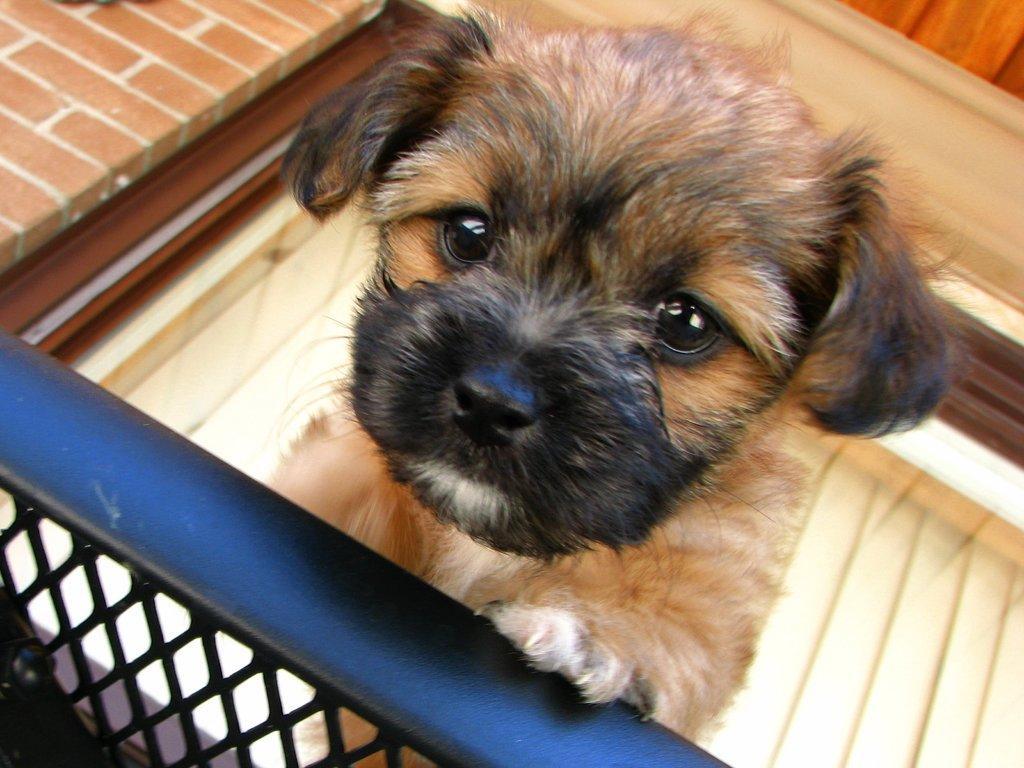Could you give a brief overview of what you see in this image? In this image I can see a puppy is looking at the picture. At the bottom there is a railing. In the background there is a wall. This is a part of a building. 